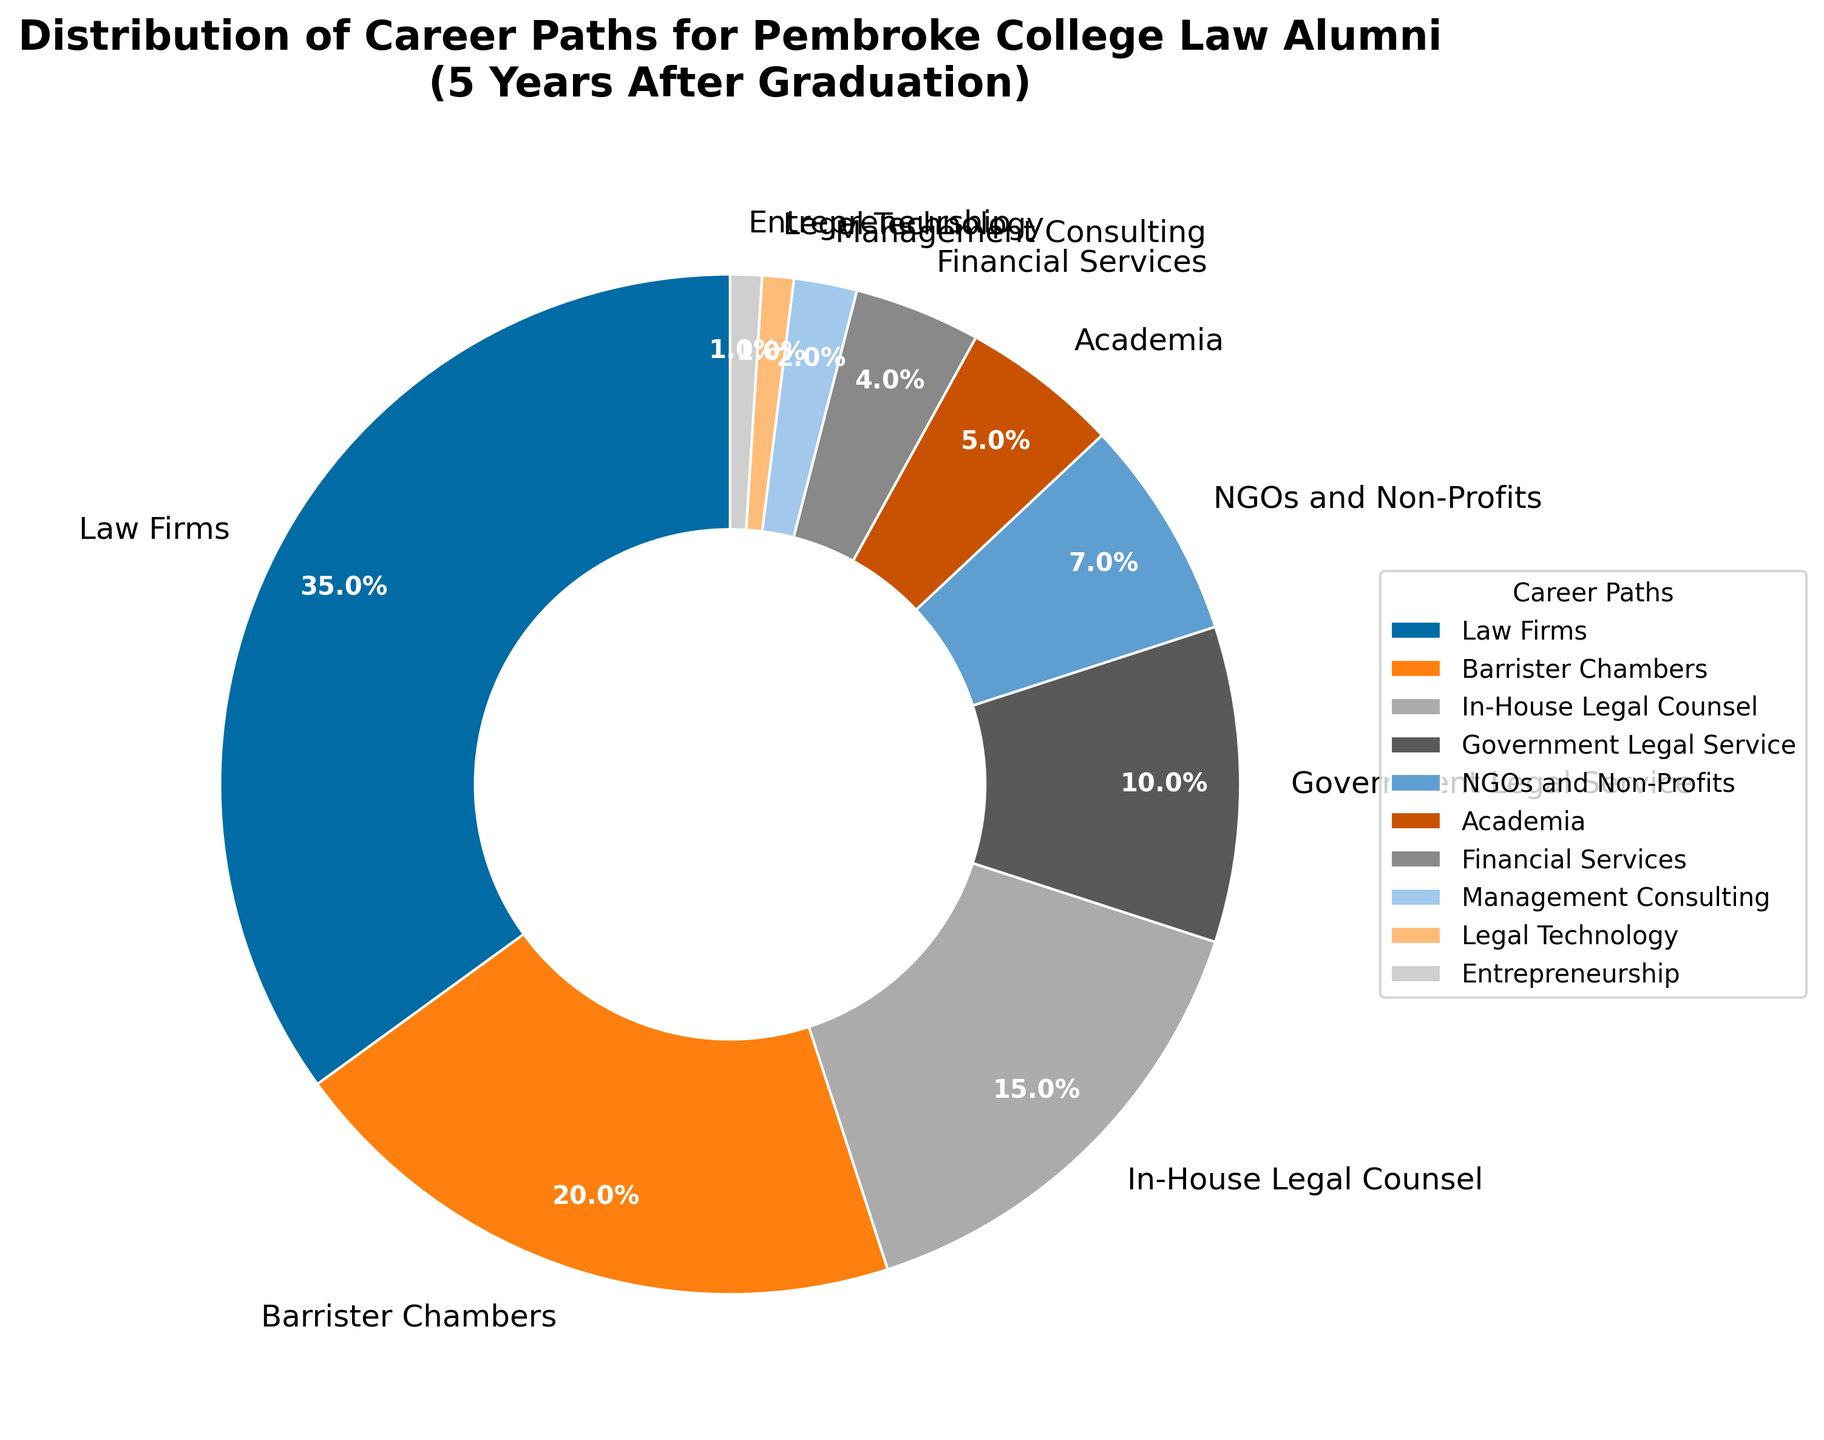Which career path has the highest percentage of Pembroke College law alumni? The chart shows various career paths with percentages. The largest portion visually tagged with the highest percentage is "Law Firms" at 35%.
Answer: Law Firms How do the percentages of alumni in Barrister Chambers and In-House Legal Counsel compare? The chart labels "Barrister Chambers" at 20% and "In-House Legal Counsel" at 15%. Visually, you can see that Barrister Chambers has a higher percentage.
Answer: Barrister Chambers has a higher percentage Which career path has the smallest percentage of Pembroke College law alumni? By examining the chart, the smallest wedge is labeled with 1%. The career paths corresponding to this percentage are "Legal Technology" and "Entrepreneurship."
Answer: Legal Technology and Entrepreneurship What is the combined percentage of Pembroke College law alumni working in NGOs and Non-Profits, and Academia? The chart shows NGOs and Non-Profits at 7%, and Academia at 5%. Adding these together: 7% + 5% = 12%.
Answer: 12% Which has a higher percentage: alumni in Management Consulting or Financial Services, and by how much? The chart indicates Financial Services at 4% and Management Consulting at 2%. The difference between these percentages is 4% - 2% = 2%.
Answer: Financial Services by 2% What fraction of Pembroke College law alumni work in legal-related jobs (Law Firms, Barrister Chambers, In-House Legal Counsel, Government Legal Service)? Sum the percentages for Law Firms (35%), Barrister Chambers (20%), In-House Legal Counsel (15%), and Government Legal Service (10%): 35% + 20% + 15% + 10% = 80%.
Answer: 80% Are there more alumni working in Government Legal Service or Non-Profit sectors? According to the chart, the Government Legal Service has 10%, whereas the NGOs and Non-Profits sector has 7%. Therefore, more alumni work in Government Legal Service.
Answer: Government Legal Service What is the average percentage of alumni across the four lowest percentage career paths? The lowest percentage career paths are Financial Services (4%), Management Consulting (2%), Legal Technology (1%), and Entrepreneurship (1%). The average is calculated as (4% + 2% + 1% + 1%) / 4 = 2%.
Answer: 2% What is the ratio of alumni working in Barrister Chambers to those in Academia? The chart shows Barrister Chambers at 20% and Academia at 5%. The ratio is calculated as 20% / 5% = 4.
Answer: 4 How many career paths have a percentage that is less than or equal to 10%? Observing the chart, the career paths with percentages less than or equal to 10% are: Government Legal Service (10%), NGOs and Non-Profits (7%), Academia (5%), Financial Services (4%), Management Consulting (2%), Legal Technology (1%), and Entrepreneurship (1%). There are seven career paths.
Answer: 7 